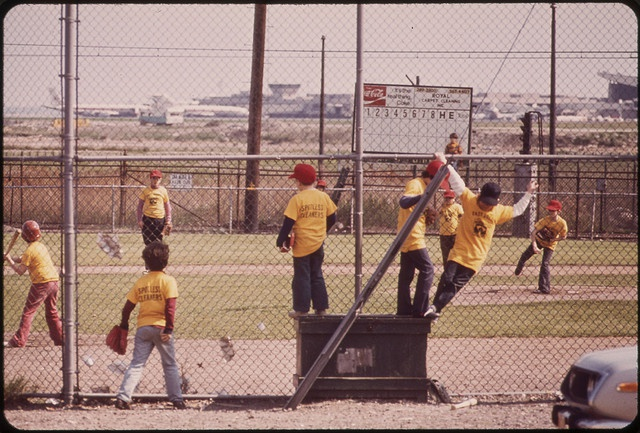Describe the objects in this image and their specific colors. I can see people in black, maroon, gray, brown, and tan tones, people in black, brown, tan, and maroon tones, people in black, tan, maroon, and brown tones, car in black, gray, and darkgray tones, and people in black, brown, and maroon tones in this image. 